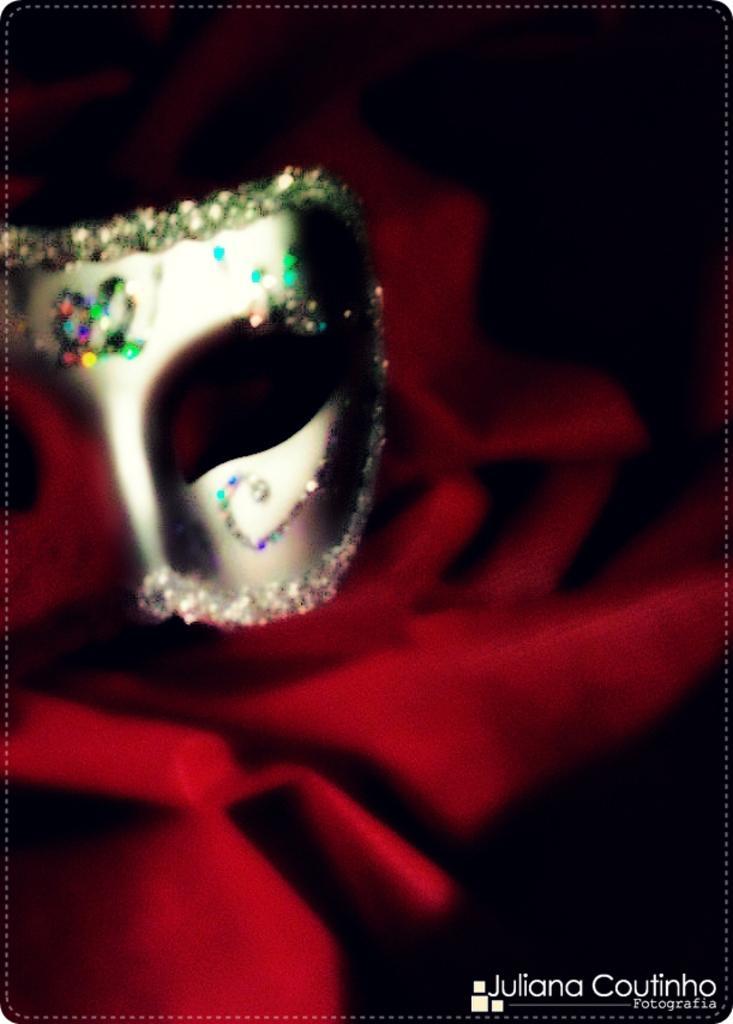Can you describe this image briefly? This image is an edited image. At the right bottom of the image there is a text on the image. On the left side of the image there is a mask with a few glitters on it. In the middle of the image there is a cloth which is dark red in color. 